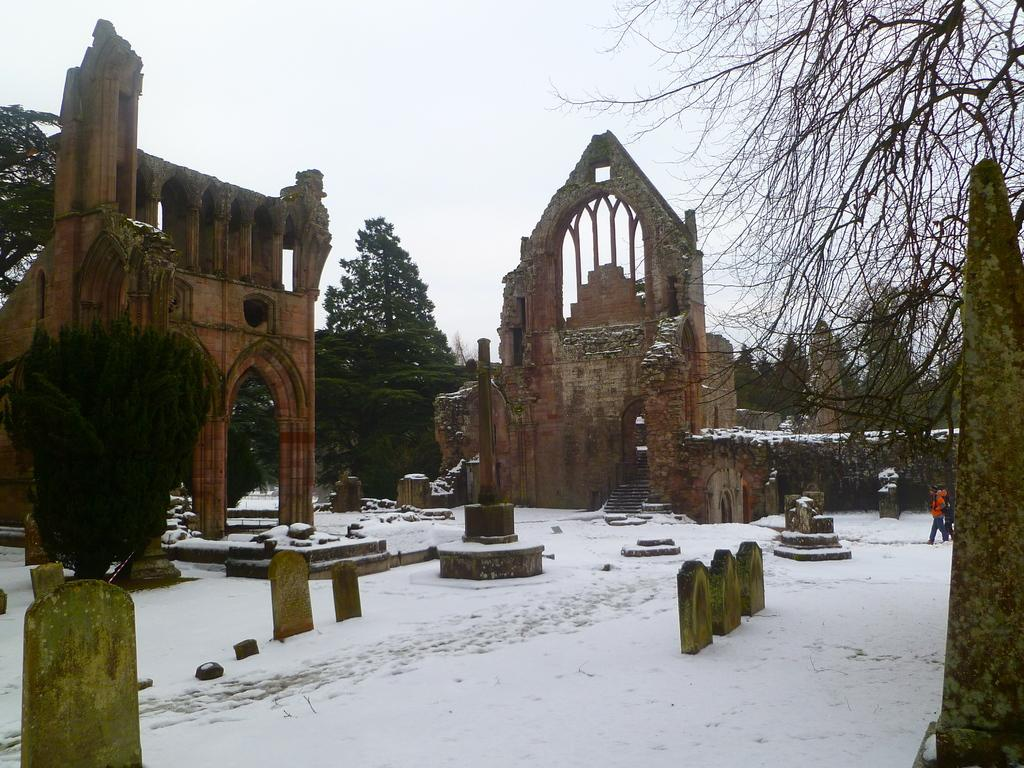What is the ground covered with in the image? There is snow on the ground in the image. What type of location is depicted in the image? The image appears to depict a graveyard. What can be seen in the front of the image? There are walls in the front of the image. What type of vegetation is present on the sides of the image? There are trees on the left and right sides of the image. What is visible at the top of the image? The sky is visible at the top of the image. What color is the pocket on the collar of the person in the image? There is no person present in the image, and therefore no pocket or collar can be observed. 